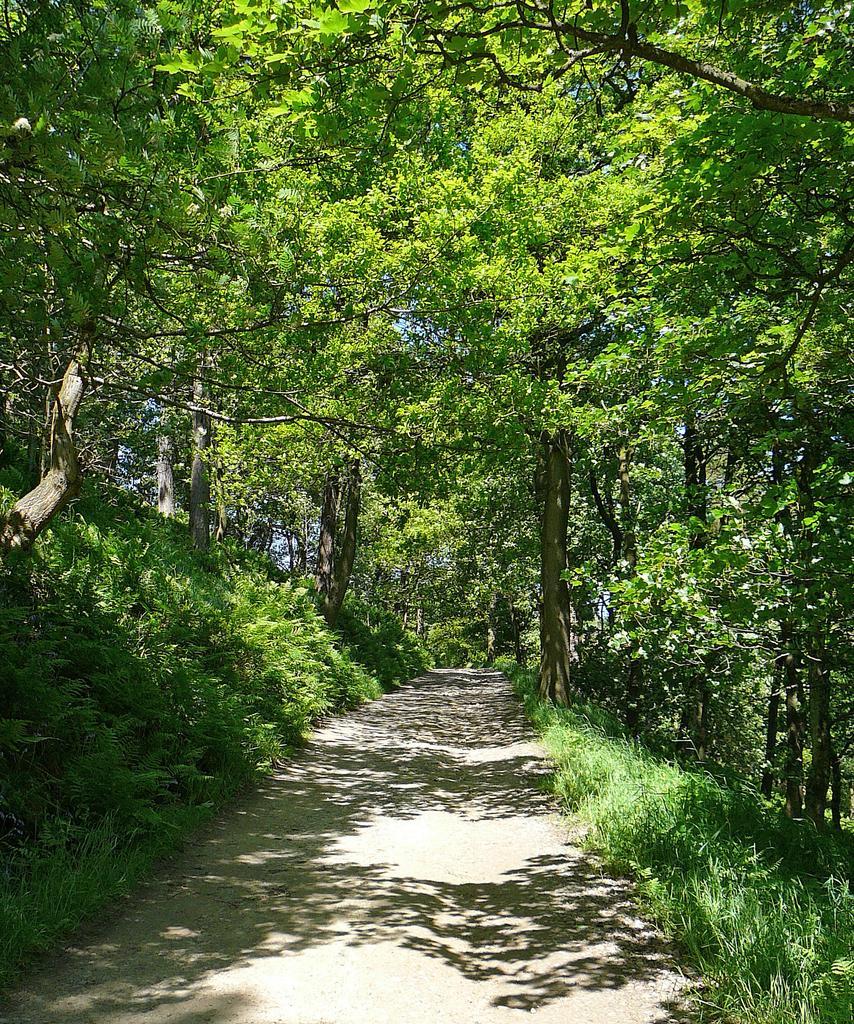Describe this image in one or two sentences. This image is taken outdoors. At the bottom of the image there is a road and there is a ground with grass on it. In the middle of the image there are many trees and plants on the ground. 